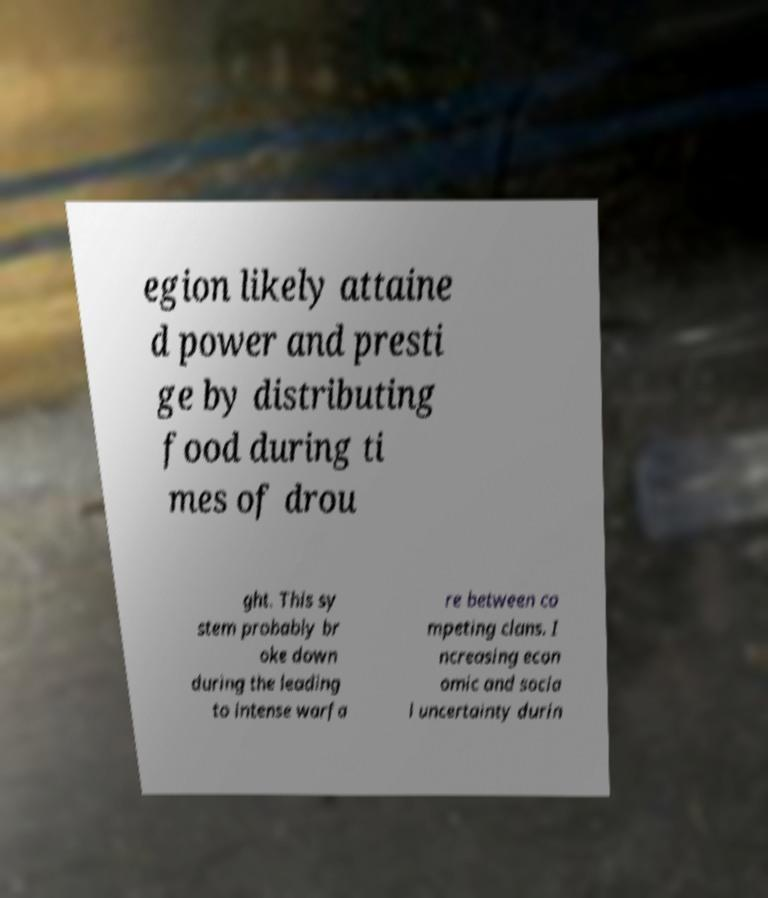Can you read and provide the text displayed in the image?This photo seems to have some interesting text. Can you extract and type it out for me? egion likely attaine d power and presti ge by distributing food during ti mes of drou ght. This sy stem probably br oke down during the leading to intense warfa re between co mpeting clans. I ncreasing econ omic and socia l uncertainty durin 